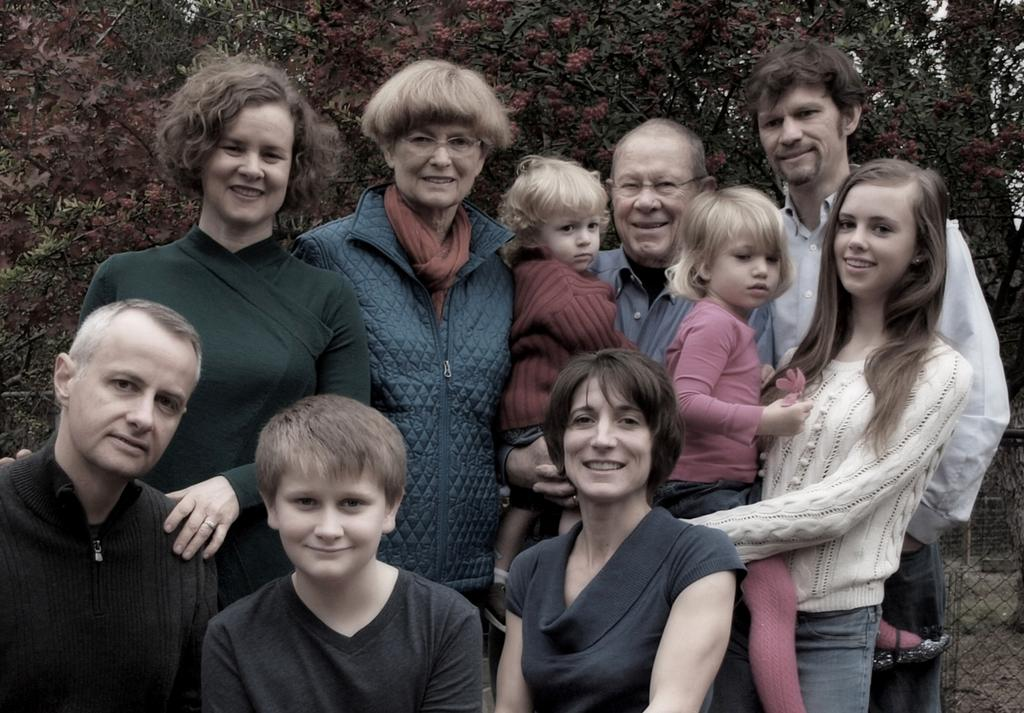What can be seen in the foreground of the image? There is a group of people in the foreground of the image. Can you describe the composition of the group? The group includes women, kids, and men. What is visible in the background of the image? There are trees in the background of the image. What is located on the right side of the image? There is fencing on the right side of the image. How many chickens are present in the image? There are no chickens present in the image. What type of beast can be seen interacting with the group of people? There is no beast present in the image; the group consists of women, kids, and men. 